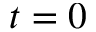<formula> <loc_0><loc_0><loc_500><loc_500>t = 0</formula> 